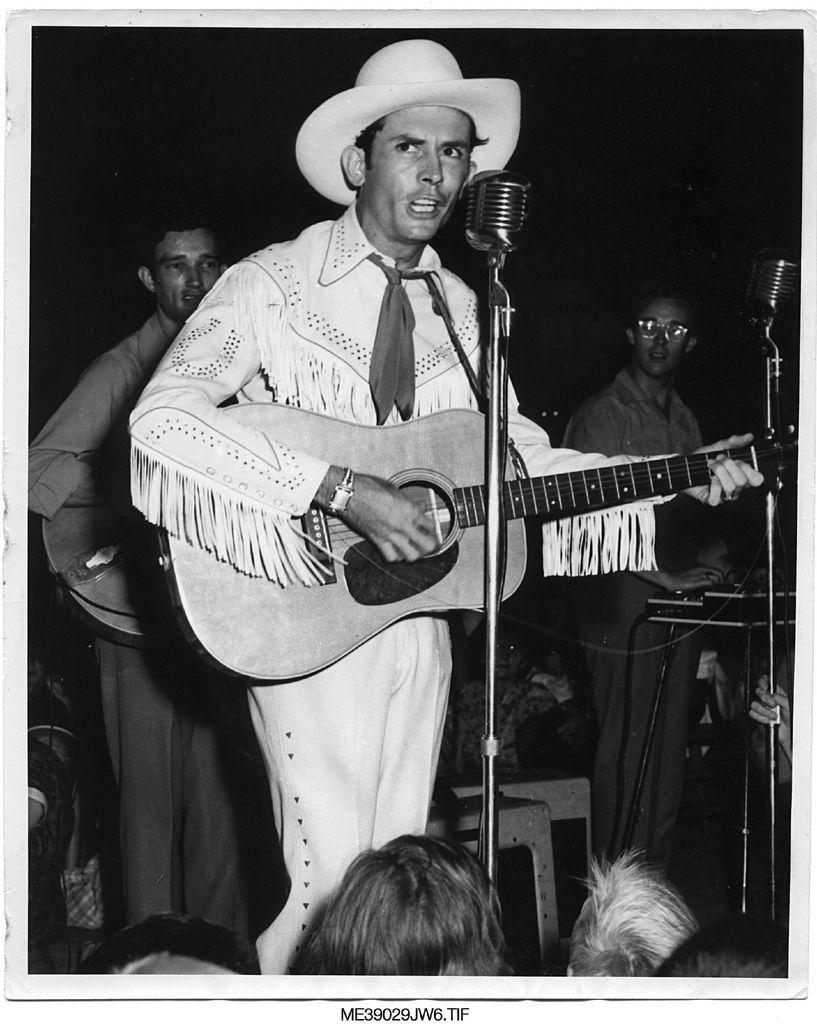Could you give a brief overview of what you see in this image? A man wearing watch, hat and tie is holding guitar and playing and singing. In front of him there is a mic and mic stand. In the back there are chairs. Also two persons are standing. Person on the left is playing guitar and person on the right wearing specs is playing organ. Also there is a mic and mic stand in the right. There are some people in the front. 